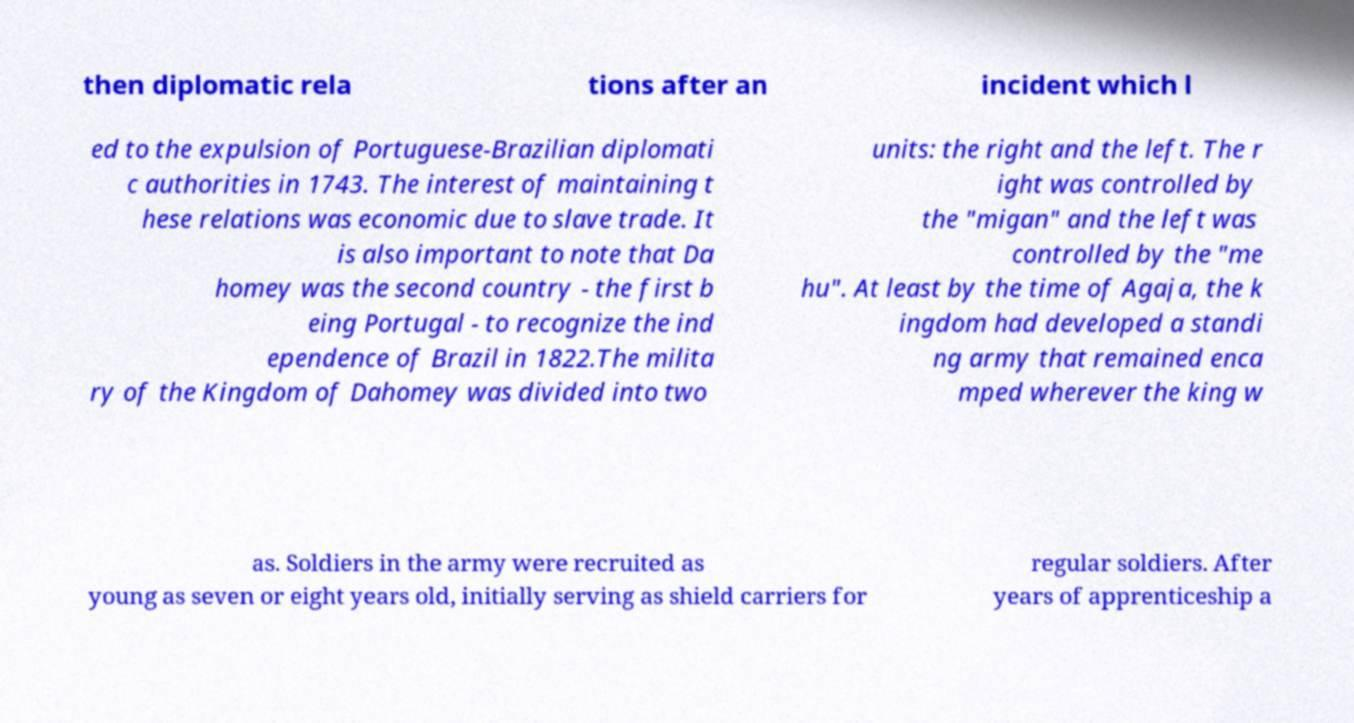Can you read and provide the text displayed in the image?This photo seems to have some interesting text. Can you extract and type it out for me? then diplomatic rela tions after an incident which l ed to the expulsion of Portuguese-Brazilian diplomati c authorities in 1743. The interest of maintaining t hese relations was economic due to slave trade. It is also important to note that Da homey was the second country - the first b eing Portugal - to recognize the ind ependence of Brazil in 1822.The milita ry of the Kingdom of Dahomey was divided into two units: the right and the left. The r ight was controlled by the "migan" and the left was controlled by the "me hu". At least by the time of Agaja, the k ingdom had developed a standi ng army that remained enca mped wherever the king w as. Soldiers in the army were recruited as young as seven or eight years old, initially serving as shield carriers for regular soldiers. After years of apprenticeship a 